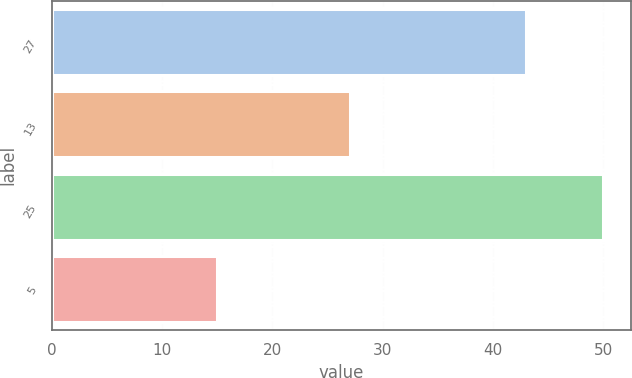Convert chart. <chart><loc_0><loc_0><loc_500><loc_500><bar_chart><fcel>27<fcel>13<fcel>25<fcel>5<nl><fcel>43<fcel>27<fcel>50<fcel>15<nl></chart> 